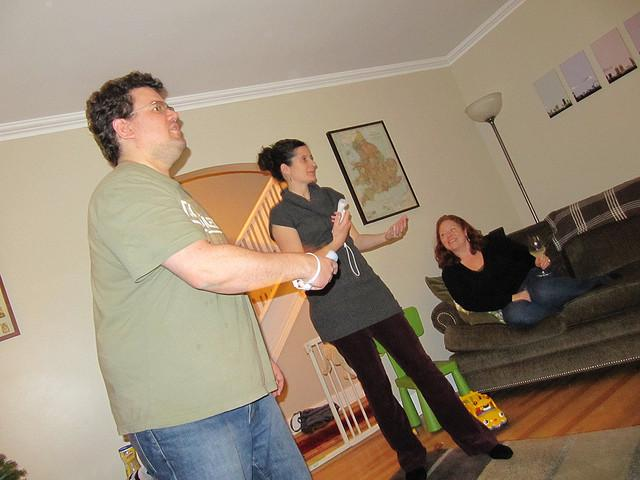What are the majority of the people doing?

Choices:
A) standing
B) eating
C) sitting
D) sleeping standing 